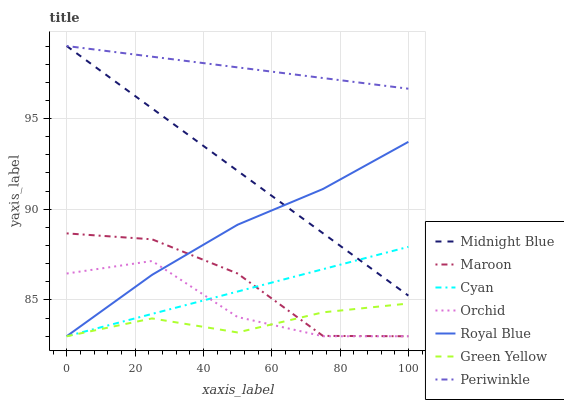Does Green Yellow have the minimum area under the curve?
Answer yes or no. Yes. Does Periwinkle have the maximum area under the curve?
Answer yes or no. Yes. Does Maroon have the minimum area under the curve?
Answer yes or no. No. Does Maroon have the maximum area under the curve?
Answer yes or no. No. Is Periwinkle the smoothest?
Answer yes or no. Yes. Is Orchid the roughest?
Answer yes or no. Yes. Is Maroon the smoothest?
Answer yes or no. No. Is Maroon the roughest?
Answer yes or no. No. Does Periwinkle have the lowest value?
Answer yes or no. No. Does Maroon have the highest value?
Answer yes or no. No. Is Green Yellow less than Midnight Blue?
Answer yes or no. Yes. Is Periwinkle greater than Maroon?
Answer yes or no. Yes. Does Green Yellow intersect Midnight Blue?
Answer yes or no. No. 